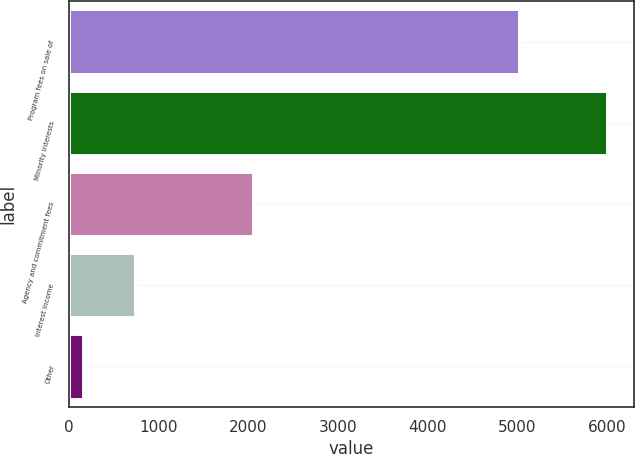Convert chart. <chart><loc_0><loc_0><loc_500><loc_500><bar_chart><fcel>Program fees on sale of<fcel>Minority interests<fcel>Agency and commitment fees<fcel>Interest income<fcel>Other<nl><fcel>5018<fcel>6001<fcel>2057<fcel>738.7<fcel>154<nl></chart> 